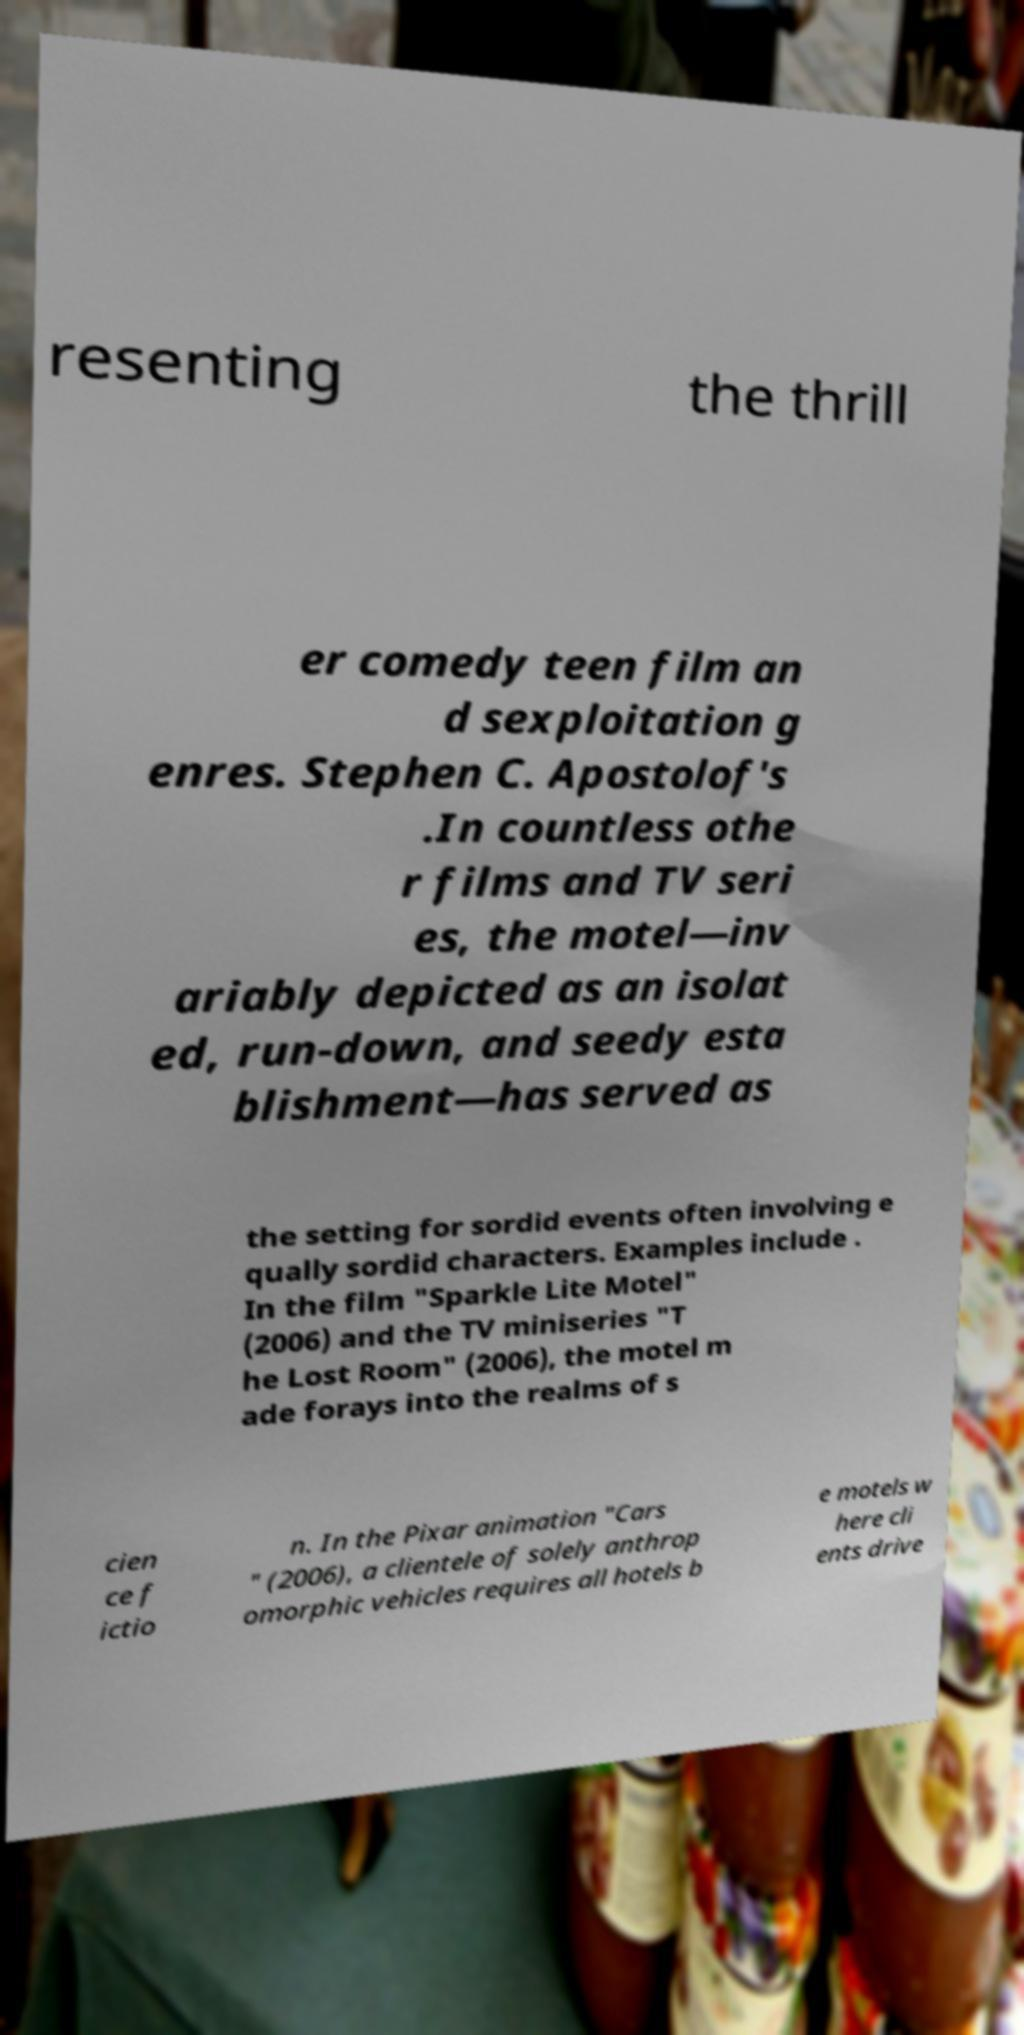There's text embedded in this image that I need extracted. Can you transcribe it verbatim? resenting the thrill er comedy teen film an d sexploitation g enres. Stephen C. Apostolof's .In countless othe r films and TV seri es, the motel—inv ariably depicted as an isolat ed, run-down, and seedy esta blishment—has served as the setting for sordid events often involving e qually sordid characters. Examples include . In the film "Sparkle Lite Motel" (2006) and the TV miniseries "T he Lost Room" (2006), the motel m ade forays into the realms of s cien ce f ictio n. In the Pixar animation "Cars " (2006), a clientele of solely anthrop omorphic vehicles requires all hotels b e motels w here cli ents drive 